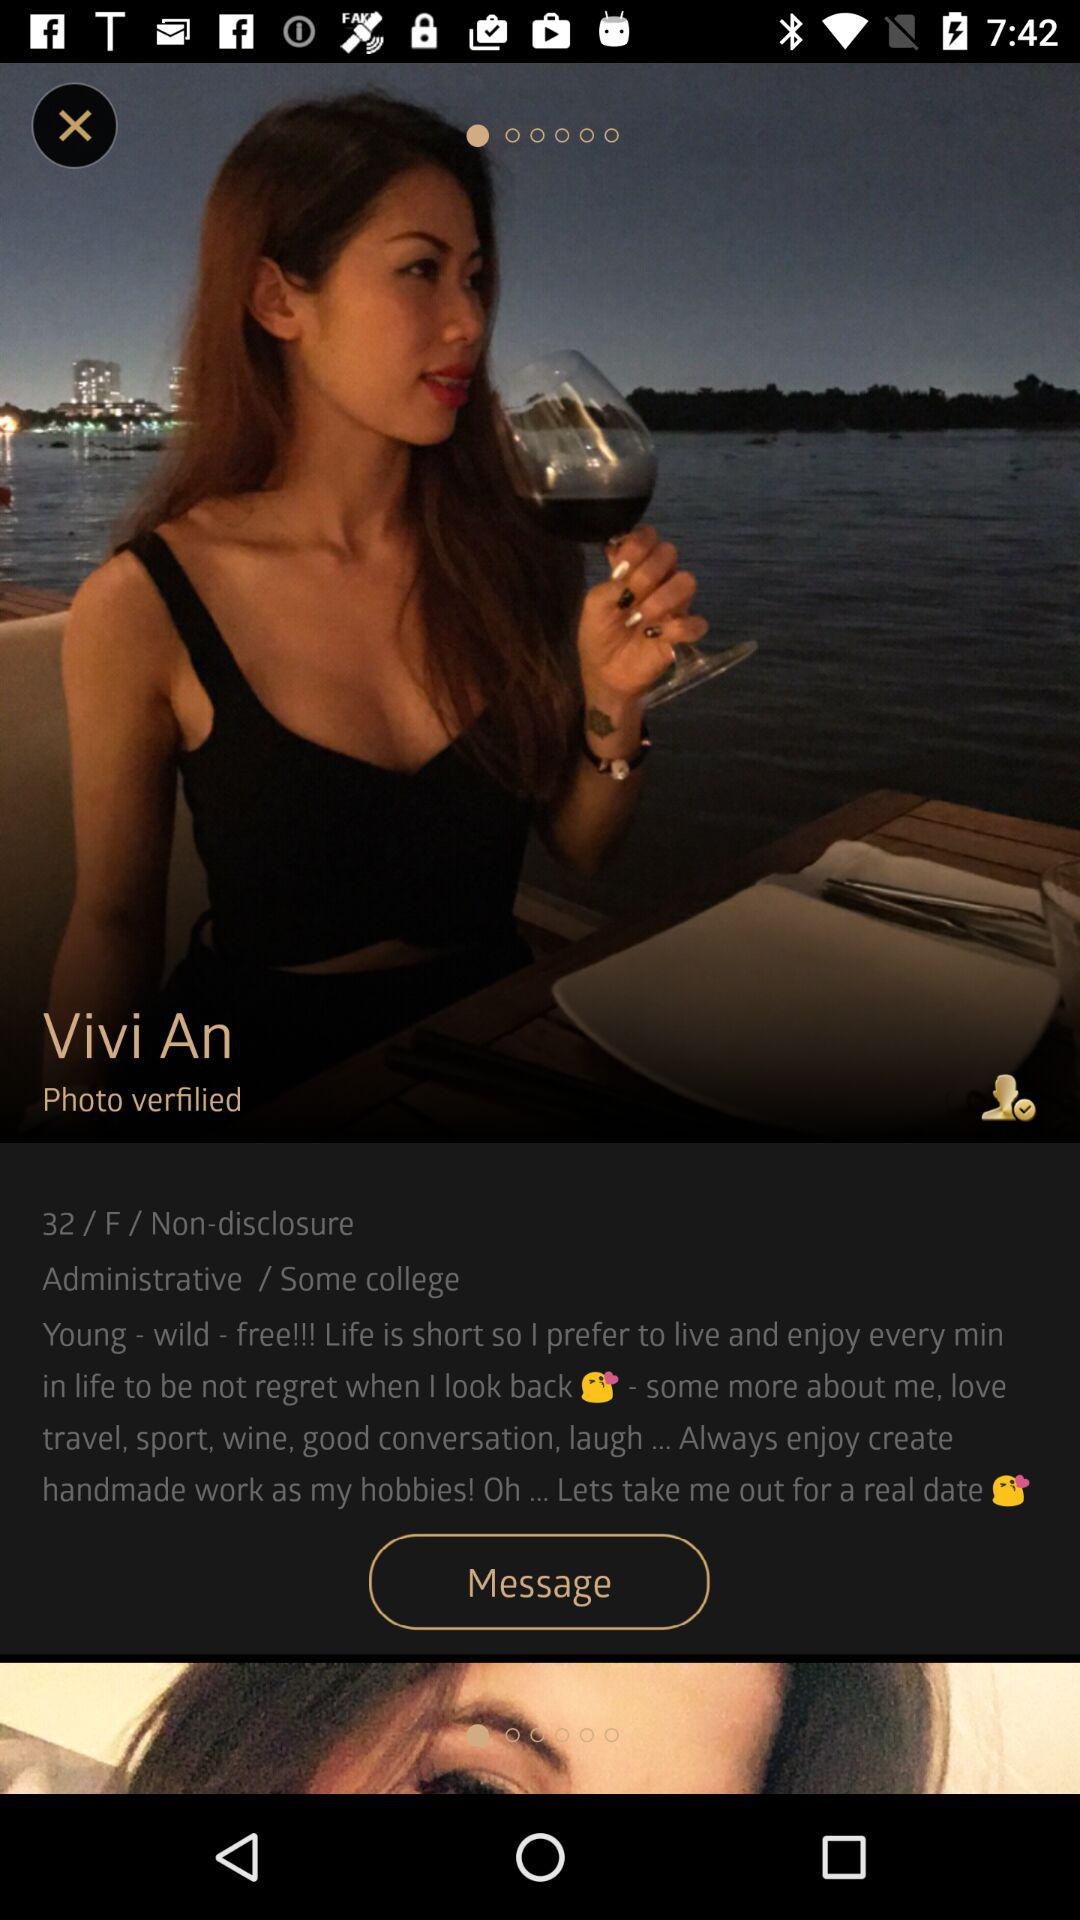What's the user profile name? The user profile name is Vivi An. 